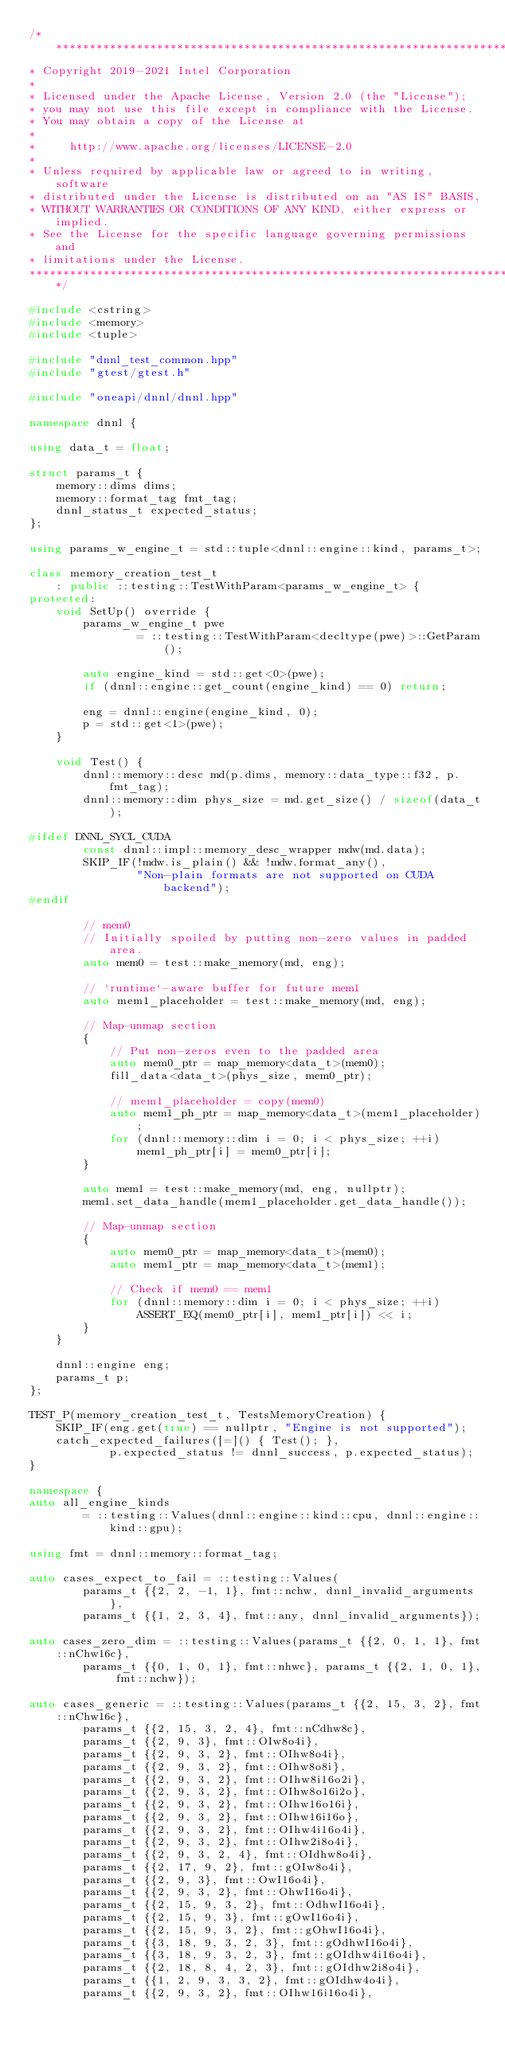Convert code to text. <code><loc_0><loc_0><loc_500><loc_500><_C++_>/*******************************************************************************
* Copyright 2019-2021 Intel Corporation
*
* Licensed under the Apache License, Version 2.0 (the "License");
* you may not use this file except in compliance with the License.
* You may obtain a copy of the License at
*
*     http://www.apache.org/licenses/LICENSE-2.0
*
* Unless required by applicable law or agreed to in writing, software
* distributed under the License is distributed on an "AS IS" BASIS,
* WITHOUT WARRANTIES OR CONDITIONS OF ANY KIND, either express or implied.
* See the License for the specific language governing permissions and
* limitations under the License.
*******************************************************************************/

#include <cstring>
#include <memory>
#include <tuple>

#include "dnnl_test_common.hpp"
#include "gtest/gtest.h"

#include "oneapi/dnnl/dnnl.hpp"

namespace dnnl {

using data_t = float;

struct params_t {
    memory::dims dims;
    memory::format_tag fmt_tag;
    dnnl_status_t expected_status;
};

using params_w_engine_t = std::tuple<dnnl::engine::kind, params_t>;

class memory_creation_test_t
    : public ::testing::TestWithParam<params_w_engine_t> {
protected:
    void SetUp() override {
        params_w_engine_t pwe
                = ::testing::TestWithParam<decltype(pwe)>::GetParam();

        auto engine_kind = std::get<0>(pwe);
        if (dnnl::engine::get_count(engine_kind) == 0) return;

        eng = dnnl::engine(engine_kind, 0);
        p = std::get<1>(pwe);
    }

    void Test() {
        dnnl::memory::desc md(p.dims, memory::data_type::f32, p.fmt_tag);
        dnnl::memory::dim phys_size = md.get_size() / sizeof(data_t);

#ifdef DNNL_SYCL_CUDA
        const dnnl::impl::memory_desc_wrapper mdw(md.data);
        SKIP_IF(!mdw.is_plain() && !mdw.format_any(),
                "Non-plain formats are not supported on CUDA backend");
#endif

        // mem0
        // Initially spoiled by putting non-zero values in padded area.
        auto mem0 = test::make_memory(md, eng);

        // `runtime`-aware buffer for future mem1
        auto mem1_placeholder = test::make_memory(md, eng);

        // Map-unmap section
        {
            // Put non-zeros even to the padded area
            auto mem0_ptr = map_memory<data_t>(mem0);
            fill_data<data_t>(phys_size, mem0_ptr);

            // mem1_placeholder = copy(mem0)
            auto mem1_ph_ptr = map_memory<data_t>(mem1_placeholder);
            for (dnnl::memory::dim i = 0; i < phys_size; ++i)
                mem1_ph_ptr[i] = mem0_ptr[i];
        }

        auto mem1 = test::make_memory(md, eng, nullptr);
        mem1.set_data_handle(mem1_placeholder.get_data_handle());

        // Map-unmap section
        {
            auto mem0_ptr = map_memory<data_t>(mem0);
            auto mem1_ptr = map_memory<data_t>(mem1);

            // Check if mem0 == mem1
            for (dnnl::memory::dim i = 0; i < phys_size; ++i)
                ASSERT_EQ(mem0_ptr[i], mem1_ptr[i]) << i;
        }
    }

    dnnl::engine eng;
    params_t p;
};

TEST_P(memory_creation_test_t, TestsMemoryCreation) {
    SKIP_IF(eng.get(true) == nullptr, "Engine is not supported");
    catch_expected_failures([=]() { Test(); },
            p.expected_status != dnnl_success, p.expected_status);
}

namespace {
auto all_engine_kinds
        = ::testing::Values(dnnl::engine::kind::cpu, dnnl::engine::kind::gpu);

using fmt = dnnl::memory::format_tag;

auto cases_expect_to_fail = ::testing::Values(
        params_t {{2, 2, -1, 1}, fmt::nchw, dnnl_invalid_arguments},
        params_t {{1, 2, 3, 4}, fmt::any, dnnl_invalid_arguments});

auto cases_zero_dim = ::testing::Values(params_t {{2, 0, 1, 1}, fmt::nChw16c},
        params_t {{0, 1, 0, 1}, fmt::nhwc}, params_t {{2, 1, 0, 1}, fmt::nchw});

auto cases_generic = ::testing::Values(params_t {{2, 15, 3, 2}, fmt::nChw16c},
        params_t {{2, 15, 3, 2, 4}, fmt::nCdhw8c},
        params_t {{2, 9, 3}, fmt::OIw8o4i},
        params_t {{2, 9, 3, 2}, fmt::OIhw8o4i},
        params_t {{2, 9, 3, 2}, fmt::OIhw8o8i},
        params_t {{2, 9, 3, 2}, fmt::OIhw8i16o2i},
        params_t {{2, 9, 3, 2}, fmt::OIhw8o16i2o},
        params_t {{2, 9, 3, 2}, fmt::OIhw16o16i},
        params_t {{2, 9, 3, 2}, fmt::OIhw16i16o},
        params_t {{2, 9, 3, 2}, fmt::OIhw4i16o4i},
        params_t {{2, 9, 3, 2}, fmt::OIhw2i8o4i},
        params_t {{2, 9, 3, 2, 4}, fmt::OIdhw8o4i},
        params_t {{2, 17, 9, 2}, fmt::gOIw8o4i},
        params_t {{2, 9, 3}, fmt::OwI16o4i},
        params_t {{2, 9, 3, 2}, fmt::OhwI16o4i},
        params_t {{2, 15, 9, 3, 2}, fmt::OdhwI16o4i},
        params_t {{2, 15, 9, 3}, fmt::gOwI16o4i},
        params_t {{2, 15, 9, 3, 2}, fmt::gOhwI16o4i},
        params_t {{3, 18, 9, 3, 2, 3}, fmt::gOdhwI16o4i},
        params_t {{3, 18, 9, 3, 2, 3}, fmt::gOIdhw4i16o4i},
        params_t {{2, 18, 8, 4, 2, 3}, fmt::gOIdhw2i8o4i},
        params_t {{1, 2, 9, 3, 3, 2}, fmt::gOIdhw4o4i},
        params_t {{2, 9, 3, 2}, fmt::OIhw16i16o4i},</code> 